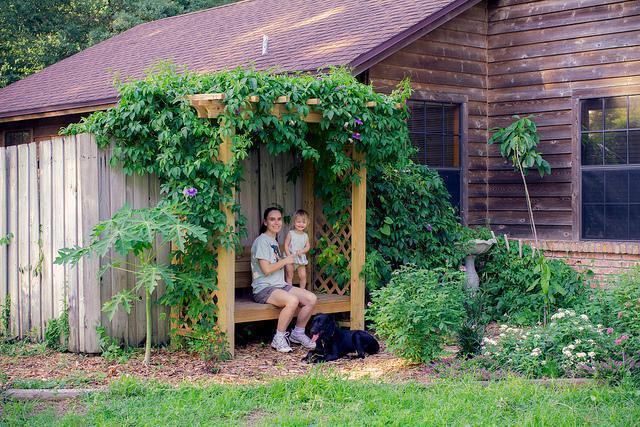How many children are in the picture?
Give a very brief answer. 1. How many dogs are in the photo?
Give a very brief answer. 1. 